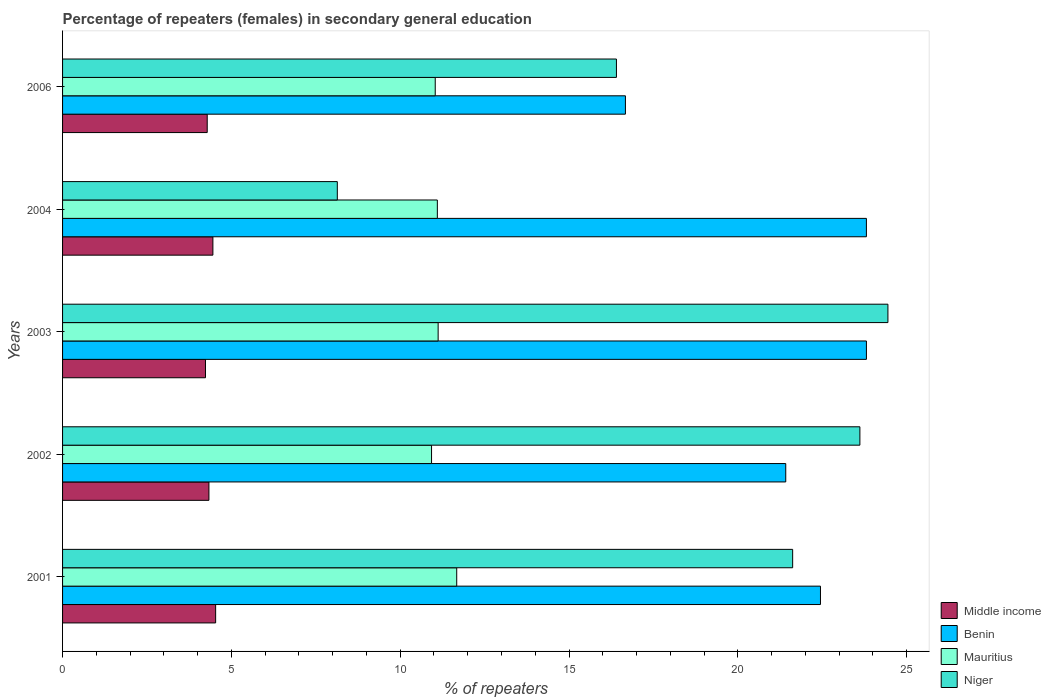Are the number of bars per tick equal to the number of legend labels?
Your answer should be very brief. Yes. How many bars are there on the 5th tick from the bottom?
Provide a succinct answer. 4. What is the label of the 4th group of bars from the top?
Keep it short and to the point. 2002. What is the percentage of female repeaters in Benin in 2002?
Offer a terse response. 21.42. Across all years, what is the maximum percentage of female repeaters in Middle income?
Offer a very short reply. 4.53. Across all years, what is the minimum percentage of female repeaters in Niger?
Keep it short and to the point. 8.14. In which year was the percentage of female repeaters in Mauritius minimum?
Offer a very short reply. 2002. What is the total percentage of female repeaters in Middle income in the graph?
Keep it short and to the point. 21.84. What is the difference between the percentage of female repeaters in Mauritius in 2002 and that in 2006?
Ensure brevity in your answer.  -0.11. What is the difference between the percentage of female repeaters in Niger in 2003 and the percentage of female repeaters in Benin in 2002?
Offer a very short reply. 3.03. What is the average percentage of female repeaters in Benin per year?
Your response must be concise. 21.63. In the year 2006, what is the difference between the percentage of female repeaters in Niger and percentage of female repeaters in Benin?
Keep it short and to the point. -0.27. What is the ratio of the percentage of female repeaters in Niger in 2003 to that in 2006?
Give a very brief answer. 1.49. Is the percentage of female repeaters in Benin in 2002 less than that in 2006?
Provide a short and direct response. No. What is the difference between the highest and the second highest percentage of female repeaters in Niger?
Keep it short and to the point. 0.83. What is the difference between the highest and the lowest percentage of female repeaters in Benin?
Keep it short and to the point. 7.14. In how many years, is the percentage of female repeaters in Niger greater than the average percentage of female repeaters in Niger taken over all years?
Your answer should be compact. 3. Is the sum of the percentage of female repeaters in Niger in 2001 and 2003 greater than the maximum percentage of female repeaters in Benin across all years?
Provide a succinct answer. Yes. What does the 2nd bar from the top in 2002 represents?
Your answer should be compact. Mauritius. What does the 3rd bar from the bottom in 2001 represents?
Provide a short and direct response. Mauritius. How many years are there in the graph?
Give a very brief answer. 5. What is the difference between two consecutive major ticks on the X-axis?
Offer a very short reply. 5. Are the values on the major ticks of X-axis written in scientific E-notation?
Your response must be concise. No. Does the graph contain grids?
Make the answer very short. No. How many legend labels are there?
Your answer should be very brief. 4. What is the title of the graph?
Ensure brevity in your answer.  Percentage of repeaters (females) in secondary general education. Does "Botswana" appear as one of the legend labels in the graph?
Make the answer very short. No. What is the label or title of the X-axis?
Ensure brevity in your answer.  % of repeaters. What is the label or title of the Y-axis?
Give a very brief answer. Years. What is the % of repeaters in Middle income in 2001?
Provide a succinct answer. 4.53. What is the % of repeaters in Benin in 2001?
Provide a short and direct response. 22.45. What is the % of repeaters of Mauritius in 2001?
Your answer should be compact. 11.67. What is the % of repeaters of Niger in 2001?
Your response must be concise. 21.62. What is the % of repeaters of Middle income in 2002?
Keep it short and to the point. 4.34. What is the % of repeaters in Benin in 2002?
Your response must be concise. 21.42. What is the % of repeaters in Mauritius in 2002?
Make the answer very short. 10.93. What is the % of repeaters of Niger in 2002?
Your answer should be compact. 23.62. What is the % of repeaters in Middle income in 2003?
Your answer should be very brief. 4.23. What is the % of repeaters of Benin in 2003?
Your response must be concise. 23.81. What is the % of repeaters of Mauritius in 2003?
Ensure brevity in your answer.  11.12. What is the % of repeaters of Niger in 2003?
Provide a succinct answer. 24.45. What is the % of repeaters in Middle income in 2004?
Your response must be concise. 4.45. What is the % of repeaters of Benin in 2004?
Give a very brief answer. 23.81. What is the % of repeaters of Mauritius in 2004?
Give a very brief answer. 11.1. What is the % of repeaters of Niger in 2004?
Keep it short and to the point. 8.14. What is the % of repeaters of Middle income in 2006?
Provide a succinct answer. 4.28. What is the % of repeaters of Benin in 2006?
Ensure brevity in your answer.  16.67. What is the % of repeaters in Mauritius in 2006?
Offer a very short reply. 11.04. What is the % of repeaters in Niger in 2006?
Provide a short and direct response. 16.41. Across all years, what is the maximum % of repeaters of Middle income?
Keep it short and to the point. 4.53. Across all years, what is the maximum % of repeaters in Benin?
Your answer should be compact. 23.81. Across all years, what is the maximum % of repeaters of Mauritius?
Offer a very short reply. 11.67. Across all years, what is the maximum % of repeaters of Niger?
Keep it short and to the point. 24.45. Across all years, what is the minimum % of repeaters of Middle income?
Ensure brevity in your answer.  4.23. Across all years, what is the minimum % of repeaters of Benin?
Offer a very short reply. 16.67. Across all years, what is the minimum % of repeaters in Mauritius?
Give a very brief answer. 10.93. Across all years, what is the minimum % of repeaters in Niger?
Offer a very short reply. 8.14. What is the total % of repeaters of Middle income in the graph?
Your answer should be compact. 21.84. What is the total % of repeaters in Benin in the graph?
Ensure brevity in your answer.  108.16. What is the total % of repeaters in Mauritius in the graph?
Offer a terse response. 55.87. What is the total % of repeaters in Niger in the graph?
Your answer should be compact. 94.23. What is the difference between the % of repeaters of Middle income in 2001 and that in 2002?
Make the answer very short. 0.2. What is the difference between the % of repeaters of Benin in 2001 and that in 2002?
Offer a terse response. 1.03. What is the difference between the % of repeaters of Mauritius in 2001 and that in 2002?
Provide a succinct answer. 0.75. What is the difference between the % of repeaters of Niger in 2001 and that in 2002?
Your response must be concise. -1.99. What is the difference between the % of repeaters in Middle income in 2001 and that in 2003?
Give a very brief answer. 0.3. What is the difference between the % of repeaters of Benin in 2001 and that in 2003?
Your response must be concise. -1.36. What is the difference between the % of repeaters in Mauritius in 2001 and that in 2003?
Your answer should be very brief. 0.55. What is the difference between the % of repeaters of Niger in 2001 and that in 2003?
Your answer should be compact. -2.82. What is the difference between the % of repeaters in Middle income in 2001 and that in 2004?
Offer a terse response. 0.08. What is the difference between the % of repeaters in Benin in 2001 and that in 2004?
Your answer should be compact. -1.36. What is the difference between the % of repeaters of Mauritius in 2001 and that in 2004?
Give a very brief answer. 0.57. What is the difference between the % of repeaters of Niger in 2001 and that in 2004?
Offer a very short reply. 13.49. What is the difference between the % of repeaters of Middle income in 2001 and that in 2006?
Provide a succinct answer. 0.25. What is the difference between the % of repeaters of Benin in 2001 and that in 2006?
Your answer should be very brief. 5.78. What is the difference between the % of repeaters of Mauritius in 2001 and that in 2006?
Provide a succinct answer. 0.64. What is the difference between the % of repeaters in Niger in 2001 and that in 2006?
Offer a very short reply. 5.22. What is the difference between the % of repeaters of Middle income in 2002 and that in 2003?
Your answer should be very brief. 0.1. What is the difference between the % of repeaters of Benin in 2002 and that in 2003?
Ensure brevity in your answer.  -2.39. What is the difference between the % of repeaters in Mauritius in 2002 and that in 2003?
Give a very brief answer. -0.2. What is the difference between the % of repeaters in Niger in 2002 and that in 2003?
Your answer should be very brief. -0.83. What is the difference between the % of repeaters of Middle income in 2002 and that in 2004?
Make the answer very short. -0.12. What is the difference between the % of repeaters of Benin in 2002 and that in 2004?
Offer a terse response. -2.39. What is the difference between the % of repeaters in Mauritius in 2002 and that in 2004?
Provide a succinct answer. -0.17. What is the difference between the % of repeaters of Niger in 2002 and that in 2004?
Make the answer very short. 15.48. What is the difference between the % of repeaters of Middle income in 2002 and that in 2006?
Offer a terse response. 0.05. What is the difference between the % of repeaters in Benin in 2002 and that in 2006?
Your response must be concise. 4.75. What is the difference between the % of repeaters of Mauritius in 2002 and that in 2006?
Offer a very short reply. -0.11. What is the difference between the % of repeaters in Niger in 2002 and that in 2006?
Your response must be concise. 7.21. What is the difference between the % of repeaters of Middle income in 2003 and that in 2004?
Offer a very short reply. -0.22. What is the difference between the % of repeaters of Mauritius in 2003 and that in 2004?
Your answer should be very brief. 0.02. What is the difference between the % of repeaters of Niger in 2003 and that in 2004?
Keep it short and to the point. 16.31. What is the difference between the % of repeaters of Middle income in 2003 and that in 2006?
Keep it short and to the point. -0.05. What is the difference between the % of repeaters of Benin in 2003 and that in 2006?
Provide a short and direct response. 7.14. What is the difference between the % of repeaters of Mauritius in 2003 and that in 2006?
Your answer should be very brief. 0.09. What is the difference between the % of repeaters of Niger in 2003 and that in 2006?
Provide a short and direct response. 8.04. What is the difference between the % of repeaters in Middle income in 2004 and that in 2006?
Your answer should be very brief. 0.17. What is the difference between the % of repeaters of Benin in 2004 and that in 2006?
Your response must be concise. 7.14. What is the difference between the % of repeaters in Mauritius in 2004 and that in 2006?
Your answer should be very brief. 0.06. What is the difference between the % of repeaters of Niger in 2004 and that in 2006?
Offer a very short reply. -8.27. What is the difference between the % of repeaters of Middle income in 2001 and the % of repeaters of Benin in 2002?
Offer a terse response. -16.89. What is the difference between the % of repeaters in Middle income in 2001 and the % of repeaters in Mauritius in 2002?
Give a very brief answer. -6.39. What is the difference between the % of repeaters of Middle income in 2001 and the % of repeaters of Niger in 2002?
Make the answer very short. -19.08. What is the difference between the % of repeaters in Benin in 2001 and the % of repeaters in Mauritius in 2002?
Your answer should be compact. 11.52. What is the difference between the % of repeaters of Benin in 2001 and the % of repeaters of Niger in 2002?
Your answer should be compact. -1.17. What is the difference between the % of repeaters in Mauritius in 2001 and the % of repeaters in Niger in 2002?
Give a very brief answer. -11.94. What is the difference between the % of repeaters of Middle income in 2001 and the % of repeaters of Benin in 2003?
Give a very brief answer. -19.28. What is the difference between the % of repeaters in Middle income in 2001 and the % of repeaters in Mauritius in 2003?
Offer a terse response. -6.59. What is the difference between the % of repeaters of Middle income in 2001 and the % of repeaters of Niger in 2003?
Keep it short and to the point. -19.91. What is the difference between the % of repeaters of Benin in 2001 and the % of repeaters of Mauritius in 2003?
Provide a short and direct response. 11.32. What is the difference between the % of repeaters in Benin in 2001 and the % of repeaters in Niger in 2003?
Give a very brief answer. -2. What is the difference between the % of repeaters in Mauritius in 2001 and the % of repeaters in Niger in 2003?
Give a very brief answer. -12.77. What is the difference between the % of repeaters of Middle income in 2001 and the % of repeaters of Benin in 2004?
Make the answer very short. -19.27. What is the difference between the % of repeaters in Middle income in 2001 and the % of repeaters in Mauritius in 2004?
Provide a short and direct response. -6.57. What is the difference between the % of repeaters of Middle income in 2001 and the % of repeaters of Niger in 2004?
Provide a succinct answer. -3.6. What is the difference between the % of repeaters of Benin in 2001 and the % of repeaters of Mauritius in 2004?
Give a very brief answer. 11.35. What is the difference between the % of repeaters in Benin in 2001 and the % of repeaters in Niger in 2004?
Provide a short and direct response. 14.31. What is the difference between the % of repeaters in Mauritius in 2001 and the % of repeaters in Niger in 2004?
Your answer should be compact. 3.54. What is the difference between the % of repeaters of Middle income in 2001 and the % of repeaters of Benin in 2006?
Offer a very short reply. -12.14. What is the difference between the % of repeaters of Middle income in 2001 and the % of repeaters of Mauritius in 2006?
Offer a terse response. -6.5. What is the difference between the % of repeaters of Middle income in 2001 and the % of repeaters of Niger in 2006?
Ensure brevity in your answer.  -11.87. What is the difference between the % of repeaters in Benin in 2001 and the % of repeaters in Mauritius in 2006?
Your response must be concise. 11.41. What is the difference between the % of repeaters in Benin in 2001 and the % of repeaters in Niger in 2006?
Make the answer very short. 6.04. What is the difference between the % of repeaters of Mauritius in 2001 and the % of repeaters of Niger in 2006?
Provide a succinct answer. -4.73. What is the difference between the % of repeaters of Middle income in 2002 and the % of repeaters of Benin in 2003?
Provide a short and direct response. -19.47. What is the difference between the % of repeaters in Middle income in 2002 and the % of repeaters in Mauritius in 2003?
Your answer should be compact. -6.79. What is the difference between the % of repeaters in Middle income in 2002 and the % of repeaters in Niger in 2003?
Provide a short and direct response. -20.11. What is the difference between the % of repeaters of Benin in 2002 and the % of repeaters of Mauritius in 2003?
Ensure brevity in your answer.  10.3. What is the difference between the % of repeaters in Benin in 2002 and the % of repeaters in Niger in 2003?
Provide a succinct answer. -3.03. What is the difference between the % of repeaters of Mauritius in 2002 and the % of repeaters of Niger in 2003?
Ensure brevity in your answer.  -13.52. What is the difference between the % of repeaters in Middle income in 2002 and the % of repeaters in Benin in 2004?
Your response must be concise. -19.47. What is the difference between the % of repeaters of Middle income in 2002 and the % of repeaters of Mauritius in 2004?
Provide a short and direct response. -6.77. What is the difference between the % of repeaters in Middle income in 2002 and the % of repeaters in Niger in 2004?
Offer a very short reply. -3.8. What is the difference between the % of repeaters of Benin in 2002 and the % of repeaters of Mauritius in 2004?
Offer a very short reply. 10.32. What is the difference between the % of repeaters in Benin in 2002 and the % of repeaters in Niger in 2004?
Make the answer very short. 13.28. What is the difference between the % of repeaters in Mauritius in 2002 and the % of repeaters in Niger in 2004?
Your response must be concise. 2.79. What is the difference between the % of repeaters of Middle income in 2002 and the % of repeaters of Benin in 2006?
Your response must be concise. -12.34. What is the difference between the % of repeaters of Middle income in 2002 and the % of repeaters of Mauritius in 2006?
Keep it short and to the point. -6.7. What is the difference between the % of repeaters of Middle income in 2002 and the % of repeaters of Niger in 2006?
Offer a very short reply. -12.07. What is the difference between the % of repeaters of Benin in 2002 and the % of repeaters of Mauritius in 2006?
Make the answer very short. 10.38. What is the difference between the % of repeaters in Benin in 2002 and the % of repeaters in Niger in 2006?
Your response must be concise. 5.01. What is the difference between the % of repeaters of Mauritius in 2002 and the % of repeaters of Niger in 2006?
Ensure brevity in your answer.  -5.48. What is the difference between the % of repeaters of Middle income in 2003 and the % of repeaters of Benin in 2004?
Provide a short and direct response. -19.58. What is the difference between the % of repeaters of Middle income in 2003 and the % of repeaters of Mauritius in 2004?
Give a very brief answer. -6.87. What is the difference between the % of repeaters of Middle income in 2003 and the % of repeaters of Niger in 2004?
Your answer should be compact. -3.9. What is the difference between the % of repeaters of Benin in 2003 and the % of repeaters of Mauritius in 2004?
Your response must be concise. 12.71. What is the difference between the % of repeaters in Benin in 2003 and the % of repeaters in Niger in 2004?
Offer a terse response. 15.67. What is the difference between the % of repeaters in Mauritius in 2003 and the % of repeaters in Niger in 2004?
Provide a succinct answer. 2.99. What is the difference between the % of repeaters of Middle income in 2003 and the % of repeaters of Benin in 2006?
Ensure brevity in your answer.  -12.44. What is the difference between the % of repeaters of Middle income in 2003 and the % of repeaters of Mauritius in 2006?
Give a very brief answer. -6.8. What is the difference between the % of repeaters of Middle income in 2003 and the % of repeaters of Niger in 2006?
Your answer should be very brief. -12.17. What is the difference between the % of repeaters of Benin in 2003 and the % of repeaters of Mauritius in 2006?
Make the answer very short. 12.77. What is the difference between the % of repeaters of Benin in 2003 and the % of repeaters of Niger in 2006?
Offer a very short reply. 7.4. What is the difference between the % of repeaters of Mauritius in 2003 and the % of repeaters of Niger in 2006?
Your answer should be compact. -5.28. What is the difference between the % of repeaters of Middle income in 2004 and the % of repeaters of Benin in 2006?
Provide a succinct answer. -12.22. What is the difference between the % of repeaters in Middle income in 2004 and the % of repeaters in Mauritius in 2006?
Make the answer very short. -6.59. What is the difference between the % of repeaters of Middle income in 2004 and the % of repeaters of Niger in 2006?
Give a very brief answer. -11.95. What is the difference between the % of repeaters in Benin in 2004 and the % of repeaters in Mauritius in 2006?
Offer a terse response. 12.77. What is the difference between the % of repeaters in Benin in 2004 and the % of repeaters in Niger in 2006?
Offer a very short reply. 7.4. What is the difference between the % of repeaters in Mauritius in 2004 and the % of repeaters in Niger in 2006?
Give a very brief answer. -5.3. What is the average % of repeaters in Middle income per year?
Your answer should be very brief. 4.37. What is the average % of repeaters in Benin per year?
Ensure brevity in your answer.  21.63. What is the average % of repeaters of Mauritius per year?
Your response must be concise. 11.17. What is the average % of repeaters of Niger per year?
Your answer should be very brief. 18.85. In the year 2001, what is the difference between the % of repeaters of Middle income and % of repeaters of Benin?
Offer a terse response. -17.91. In the year 2001, what is the difference between the % of repeaters of Middle income and % of repeaters of Mauritius?
Offer a very short reply. -7.14. In the year 2001, what is the difference between the % of repeaters of Middle income and % of repeaters of Niger?
Give a very brief answer. -17.09. In the year 2001, what is the difference between the % of repeaters in Benin and % of repeaters in Mauritius?
Provide a succinct answer. 10.77. In the year 2001, what is the difference between the % of repeaters in Benin and % of repeaters in Niger?
Your response must be concise. 0.82. In the year 2001, what is the difference between the % of repeaters in Mauritius and % of repeaters in Niger?
Your answer should be very brief. -9.95. In the year 2002, what is the difference between the % of repeaters in Middle income and % of repeaters in Benin?
Give a very brief answer. -17.08. In the year 2002, what is the difference between the % of repeaters in Middle income and % of repeaters in Mauritius?
Keep it short and to the point. -6.59. In the year 2002, what is the difference between the % of repeaters of Middle income and % of repeaters of Niger?
Keep it short and to the point. -19.28. In the year 2002, what is the difference between the % of repeaters of Benin and % of repeaters of Mauritius?
Your answer should be very brief. 10.49. In the year 2002, what is the difference between the % of repeaters in Benin and % of repeaters in Niger?
Your response must be concise. -2.2. In the year 2002, what is the difference between the % of repeaters in Mauritius and % of repeaters in Niger?
Offer a very short reply. -12.69. In the year 2003, what is the difference between the % of repeaters in Middle income and % of repeaters in Benin?
Offer a very short reply. -19.58. In the year 2003, what is the difference between the % of repeaters of Middle income and % of repeaters of Mauritius?
Offer a very short reply. -6.89. In the year 2003, what is the difference between the % of repeaters in Middle income and % of repeaters in Niger?
Offer a very short reply. -20.21. In the year 2003, what is the difference between the % of repeaters in Benin and % of repeaters in Mauritius?
Provide a short and direct response. 12.69. In the year 2003, what is the difference between the % of repeaters of Benin and % of repeaters of Niger?
Make the answer very short. -0.64. In the year 2003, what is the difference between the % of repeaters in Mauritius and % of repeaters in Niger?
Keep it short and to the point. -13.32. In the year 2004, what is the difference between the % of repeaters of Middle income and % of repeaters of Benin?
Your answer should be compact. -19.36. In the year 2004, what is the difference between the % of repeaters in Middle income and % of repeaters in Mauritius?
Ensure brevity in your answer.  -6.65. In the year 2004, what is the difference between the % of repeaters in Middle income and % of repeaters in Niger?
Give a very brief answer. -3.69. In the year 2004, what is the difference between the % of repeaters in Benin and % of repeaters in Mauritius?
Keep it short and to the point. 12.71. In the year 2004, what is the difference between the % of repeaters of Benin and % of repeaters of Niger?
Offer a terse response. 15.67. In the year 2004, what is the difference between the % of repeaters in Mauritius and % of repeaters in Niger?
Provide a succinct answer. 2.96. In the year 2006, what is the difference between the % of repeaters of Middle income and % of repeaters of Benin?
Your answer should be very brief. -12.39. In the year 2006, what is the difference between the % of repeaters in Middle income and % of repeaters in Mauritius?
Your response must be concise. -6.75. In the year 2006, what is the difference between the % of repeaters of Middle income and % of repeaters of Niger?
Make the answer very short. -12.12. In the year 2006, what is the difference between the % of repeaters in Benin and % of repeaters in Mauritius?
Your answer should be compact. 5.63. In the year 2006, what is the difference between the % of repeaters in Benin and % of repeaters in Niger?
Offer a terse response. 0.27. In the year 2006, what is the difference between the % of repeaters of Mauritius and % of repeaters of Niger?
Keep it short and to the point. -5.37. What is the ratio of the % of repeaters in Middle income in 2001 to that in 2002?
Your answer should be very brief. 1.05. What is the ratio of the % of repeaters of Benin in 2001 to that in 2002?
Offer a terse response. 1.05. What is the ratio of the % of repeaters in Mauritius in 2001 to that in 2002?
Your response must be concise. 1.07. What is the ratio of the % of repeaters of Niger in 2001 to that in 2002?
Your answer should be very brief. 0.92. What is the ratio of the % of repeaters of Middle income in 2001 to that in 2003?
Provide a short and direct response. 1.07. What is the ratio of the % of repeaters of Benin in 2001 to that in 2003?
Keep it short and to the point. 0.94. What is the ratio of the % of repeaters of Mauritius in 2001 to that in 2003?
Offer a very short reply. 1.05. What is the ratio of the % of repeaters in Niger in 2001 to that in 2003?
Give a very brief answer. 0.88. What is the ratio of the % of repeaters of Middle income in 2001 to that in 2004?
Your answer should be very brief. 1.02. What is the ratio of the % of repeaters in Benin in 2001 to that in 2004?
Make the answer very short. 0.94. What is the ratio of the % of repeaters in Mauritius in 2001 to that in 2004?
Ensure brevity in your answer.  1.05. What is the ratio of the % of repeaters of Niger in 2001 to that in 2004?
Give a very brief answer. 2.66. What is the ratio of the % of repeaters in Middle income in 2001 to that in 2006?
Ensure brevity in your answer.  1.06. What is the ratio of the % of repeaters of Benin in 2001 to that in 2006?
Make the answer very short. 1.35. What is the ratio of the % of repeaters in Mauritius in 2001 to that in 2006?
Your answer should be compact. 1.06. What is the ratio of the % of repeaters of Niger in 2001 to that in 2006?
Keep it short and to the point. 1.32. What is the ratio of the % of repeaters in Benin in 2002 to that in 2003?
Offer a terse response. 0.9. What is the ratio of the % of repeaters in Mauritius in 2002 to that in 2003?
Provide a short and direct response. 0.98. What is the ratio of the % of repeaters of Niger in 2002 to that in 2003?
Give a very brief answer. 0.97. What is the ratio of the % of repeaters of Middle income in 2002 to that in 2004?
Your answer should be compact. 0.97. What is the ratio of the % of repeaters of Benin in 2002 to that in 2004?
Provide a short and direct response. 0.9. What is the ratio of the % of repeaters in Mauritius in 2002 to that in 2004?
Provide a succinct answer. 0.98. What is the ratio of the % of repeaters of Niger in 2002 to that in 2004?
Provide a short and direct response. 2.9. What is the ratio of the % of repeaters in Middle income in 2002 to that in 2006?
Ensure brevity in your answer.  1.01. What is the ratio of the % of repeaters in Benin in 2002 to that in 2006?
Your answer should be very brief. 1.28. What is the ratio of the % of repeaters of Niger in 2002 to that in 2006?
Your answer should be compact. 1.44. What is the ratio of the % of repeaters in Middle income in 2003 to that in 2004?
Provide a succinct answer. 0.95. What is the ratio of the % of repeaters of Niger in 2003 to that in 2004?
Provide a short and direct response. 3. What is the ratio of the % of repeaters of Benin in 2003 to that in 2006?
Your answer should be compact. 1.43. What is the ratio of the % of repeaters of Niger in 2003 to that in 2006?
Provide a short and direct response. 1.49. What is the ratio of the % of repeaters of Middle income in 2004 to that in 2006?
Your answer should be compact. 1.04. What is the ratio of the % of repeaters in Benin in 2004 to that in 2006?
Offer a terse response. 1.43. What is the ratio of the % of repeaters of Niger in 2004 to that in 2006?
Keep it short and to the point. 0.5. What is the difference between the highest and the second highest % of repeaters in Middle income?
Your answer should be compact. 0.08. What is the difference between the highest and the second highest % of repeaters in Benin?
Make the answer very short. 0. What is the difference between the highest and the second highest % of repeaters in Mauritius?
Your answer should be compact. 0.55. What is the difference between the highest and the second highest % of repeaters of Niger?
Ensure brevity in your answer.  0.83. What is the difference between the highest and the lowest % of repeaters of Middle income?
Offer a very short reply. 0.3. What is the difference between the highest and the lowest % of repeaters in Benin?
Keep it short and to the point. 7.14. What is the difference between the highest and the lowest % of repeaters of Mauritius?
Your answer should be compact. 0.75. What is the difference between the highest and the lowest % of repeaters of Niger?
Give a very brief answer. 16.31. 